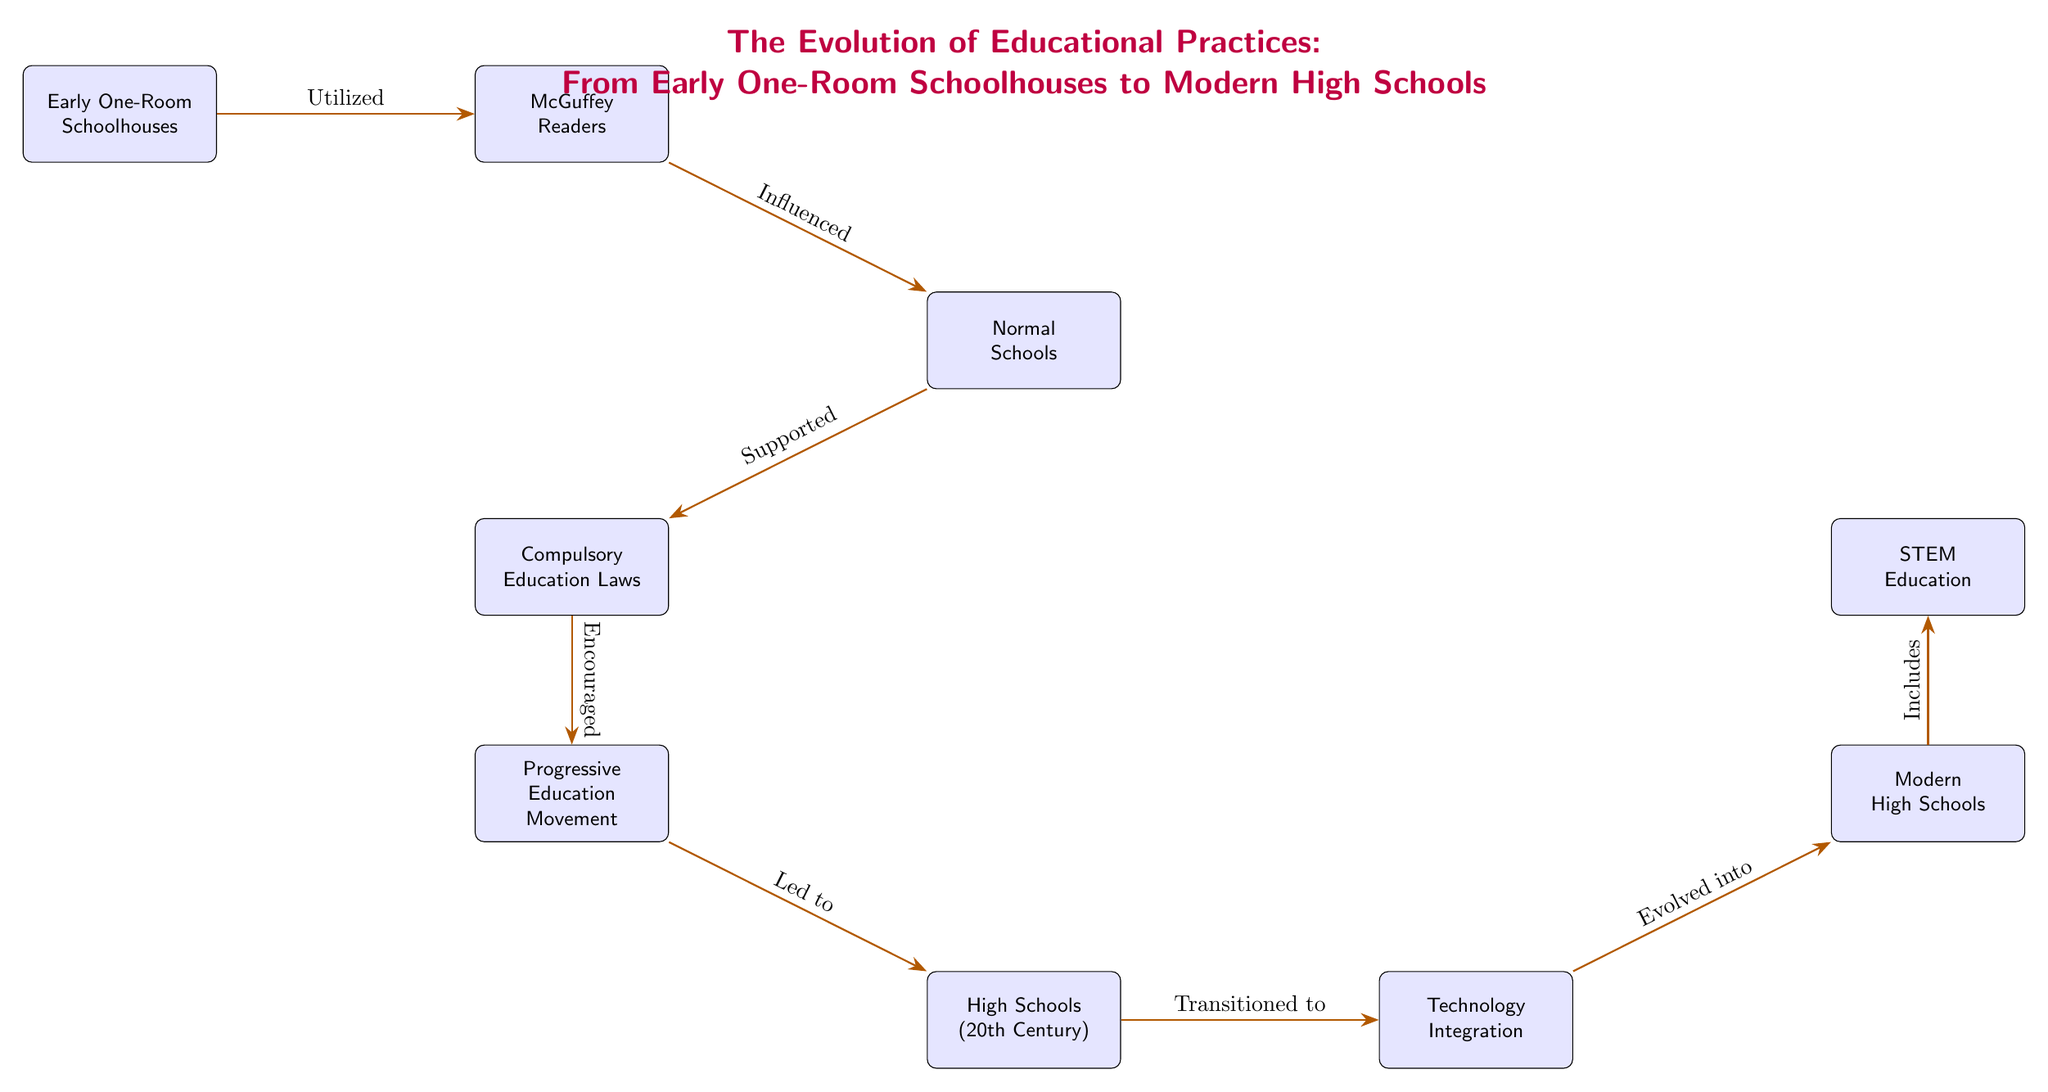What is the first node in the diagram? The first node is "Early One-Room Schoolhouses," which is positioned at the top left of the diagram.
Answer: Early One-Room Schoolhouses How many nodes are present in the diagram? By counting the boxes in the visual representation, a total of nine nodes can be identified, each representing a distinct educational concept.
Answer: 9 What does the "Progressive Education Movement" lead to? According to the diagram, the "Progressive Education Movement" directly leads to "High Schools (20th Century)," indicating a transition in educational practices.
Answer: High Schools (20th Century) Which two concepts are directly next to "Technology Integration"? The diagram shows "High Schools (20th Century)" is to the left and "Modern High Schools" is to the right of "Technology Integration," making them the direct neighbors.
Answer: High Schools (20th Century) and Modern High Schools What is the relationship between "McGuffey Readers" and "Normal Schools"? The diagram indicates that "McGuffey Readers" influenced "Normal Schools," establishing a direct cause-effect relationship between the two educational elements.
Answer: Influenced How does "Modern High Schools" relate to "STEM Education"? The diagram shows that "Modern High Schools" includes "STEM Education," demonstrating that STEM is a component within the modern high school framework.
Answer: Includes What concept supports compulsory education laws? The diagram directly connects "Normal Schools" to "Compulsory Education Laws," indicating the latter was supported by the former as part of educational evolution.
Answer: Normal Schools What educational movement encouraged the establishment of high schools? "Progressive Education Movement" is positioned to lead towards "High Schools (20th Century)," revealing that it was a driving force for their establishment.
Answer: Progressive Education Movement Which node evolves into "Modern High Schools"? The flow in the diagram shows that "Technology Integration" evolved into "Modern High Schools," marking a significant development in educational practices.
Answer: Technology Integration 